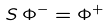Convert formula to latex. <formula><loc_0><loc_0><loc_500><loc_500>S \, { \Phi } ^ { - } = { \Phi } ^ { + }</formula> 